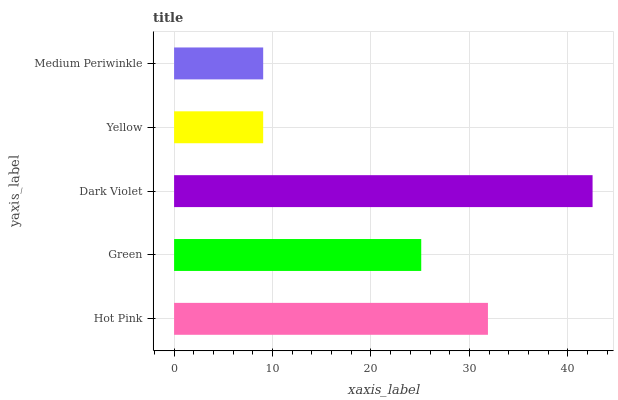Is Yellow the minimum?
Answer yes or no. Yes. Is Dark Violet the maximum?
Answer yes or no. Yes. Is Green the minimum?
Answer yes or no. No. Is Green the maximum?
Answer yes or no. No. Is Hot Pink greater than Green?
Answer yes or no. Yes. Is Green less than Hot Pink?
Answer yes or no. Yes. Is Green greater than Hot Pink?
Answer yes or no. No. Is Hot Pink less than Green?
Answer yes or no. No. Is Green the high median?
Answer yes or no. Yes. Is Green the low median?
Answer yes or no. Yes. Is Dark Violet the high median?
Answer yes or no. No. Is Yellow the low median?
Answer yes or no. No. 